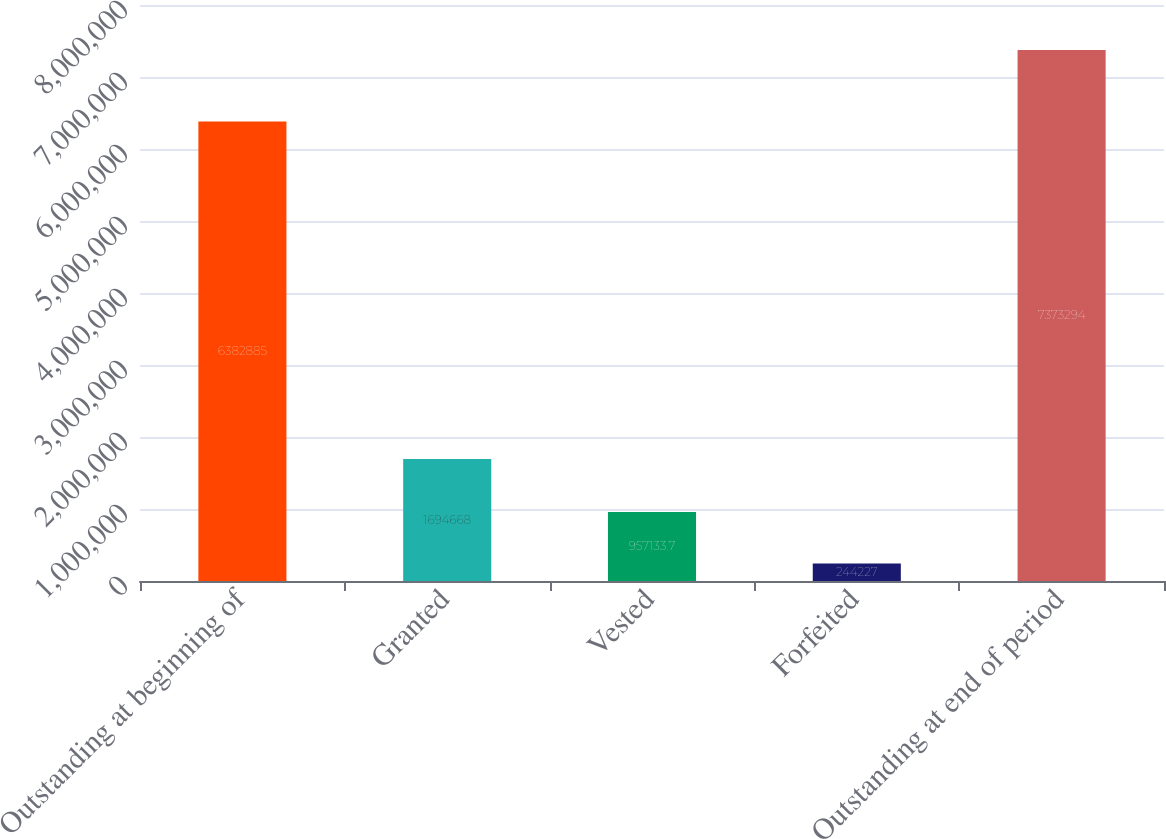Convert chart. <chart><loc_0><loc_0><loc_500><loc_500><bar_chart><fcel>Outstanding at beginning of<fcel>Granted<fcel>Vested<fcel>Forfeited<fcel>Outstanding at end of period<nl><fcel>6.38288e+06<fcel>1.69467e+06<fcel>957134<fcel>244227<fcel>7.37329e+06<nl></chart> 